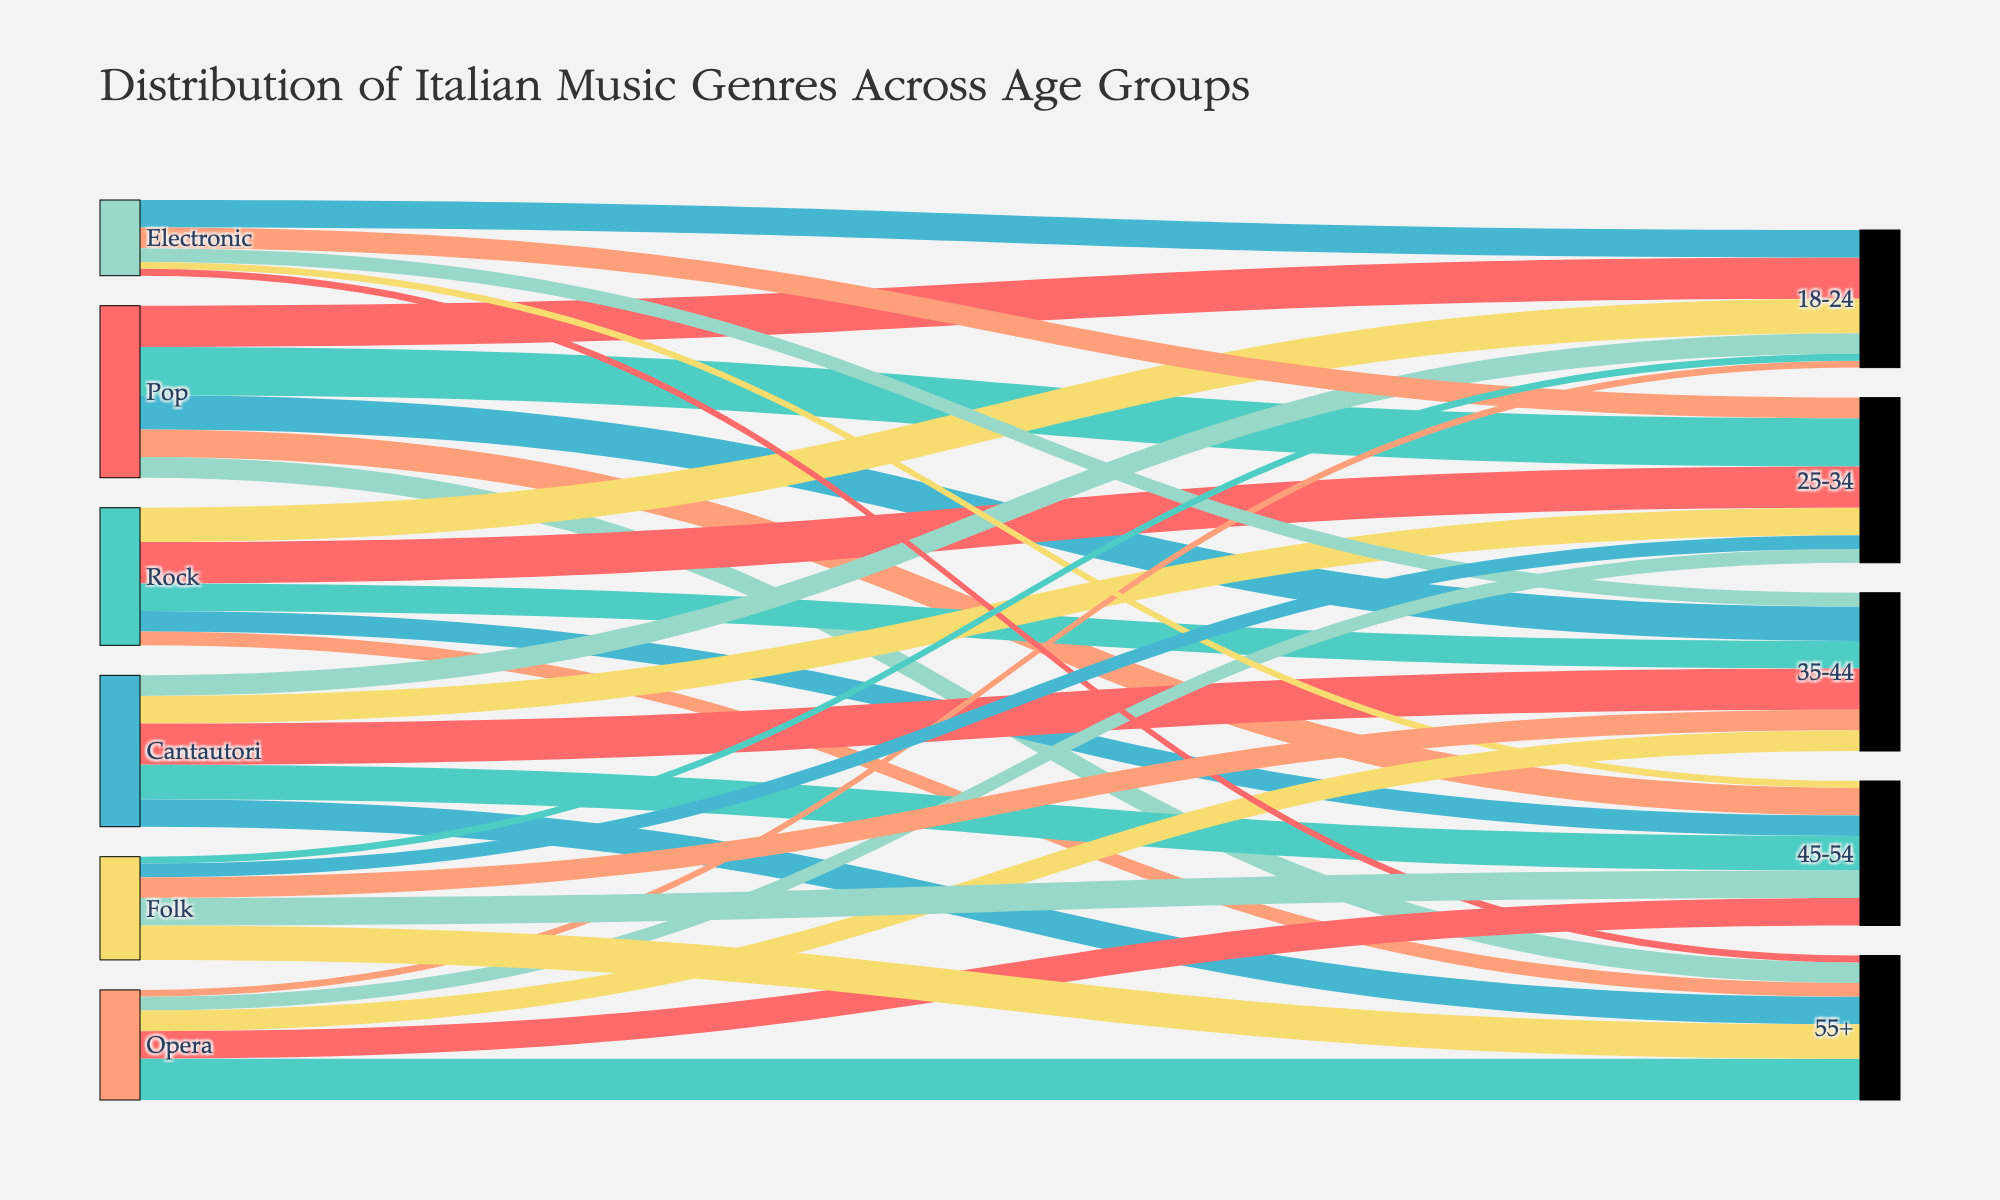Which music genre is most popular among the 18-24 age group? Look at the flow lines connecting the 18-24 age group with different music genres. The thickest line represents the most popular genre in this age group.
Answer: Pop Which age group has the highest number of fans for the Opera genre? Examine the flow lines that originate from the Opera genre and connect to different age groups. The thickest line will indicate the age group with the highest number of fans.
Answer: 55+ How many fans does Cantautori have in the 35-44 age group? Locate the flow line between Cantautori and the 35-44 age group. The value of this line represents the number of fans.
Answer: 30 Compare the popularity of Rock and Electronic genres in the 25-34 age group. Which is more popular? Observe the flow lines from Rock and Electronic to the 25-34 age group. The thicker line indicates the more popular genre.
Answer: Rock What is the total number of Pop music fans across all age groups? Sum the values of all the flow lines that start from the Pop genre and connect to different age groups: 30 + 35 + 25 + 20 + 15 = 125
Answer: 125 Which genre has the smallest number of fans among the 55+ age group? Observe the lines connected to the 55+ age group from various genres. The thinnest line will indicate the genre with the smallest number of fans.
Answer: Electronic & Pop (tie) What is the combined age group (35-44 and 45-54) fan count for the Folk genre? Add the values of the flow lines connecting Folk to the 35-44 and 45-54 age groups: 15 + 20 = 35
Answer: 35 Which genre shows an increasing trend in popularity as the age group increases? Identify the genre in which the thickness of the flow lines increases as they connect to older age groups.
Answer: Opera Compare the total number of fans for Cantautori and Electronic genres across all age groups. Which genre has more fans? Calculate the total number of fans for both genres by summing the values of the flow lines connected to each age group. Cantautori: 15 + 20 + 30 + 25 + 20 = 110; Electronic: 20 + 15 + 10 + 5 + 5 = 55. Compare the two sums.
Answer: Cantautori What's the least popular genre among the 18-24 age group? Look at the flow lines connecting the 18-24 age group with different genres. The thinnest line represents the least popular genre in this age group.
Answer: Opera & Folk (tie) 